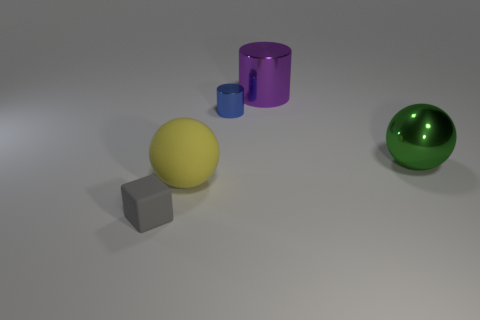Add 1 large brown metallic balls. How many objects exist? 6 Subtract all balls. How many objects are left? 3 Add 2 gray things. How many gray things are left? 3 Add 5 tiny brown metallic balls. How many tiny brown metallic balls exist? 5 Subtract 0 purple cubes. How many objects are left? 5 Subtract all big gray matte cylinders. Subtract all metal things. How many objects are left? 2 